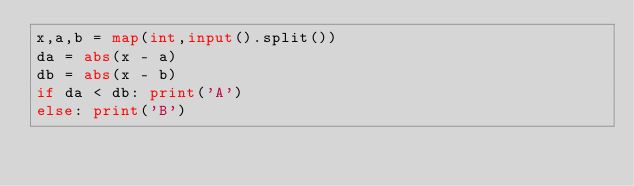<code> <loc_0><loc_0><loc_500><loc_500><_Python_>x,a,b = map(int,input().split())
da = abs(x - a)
db = abs(x - b)
if da < db: print('A')
else: print('B')</code> 